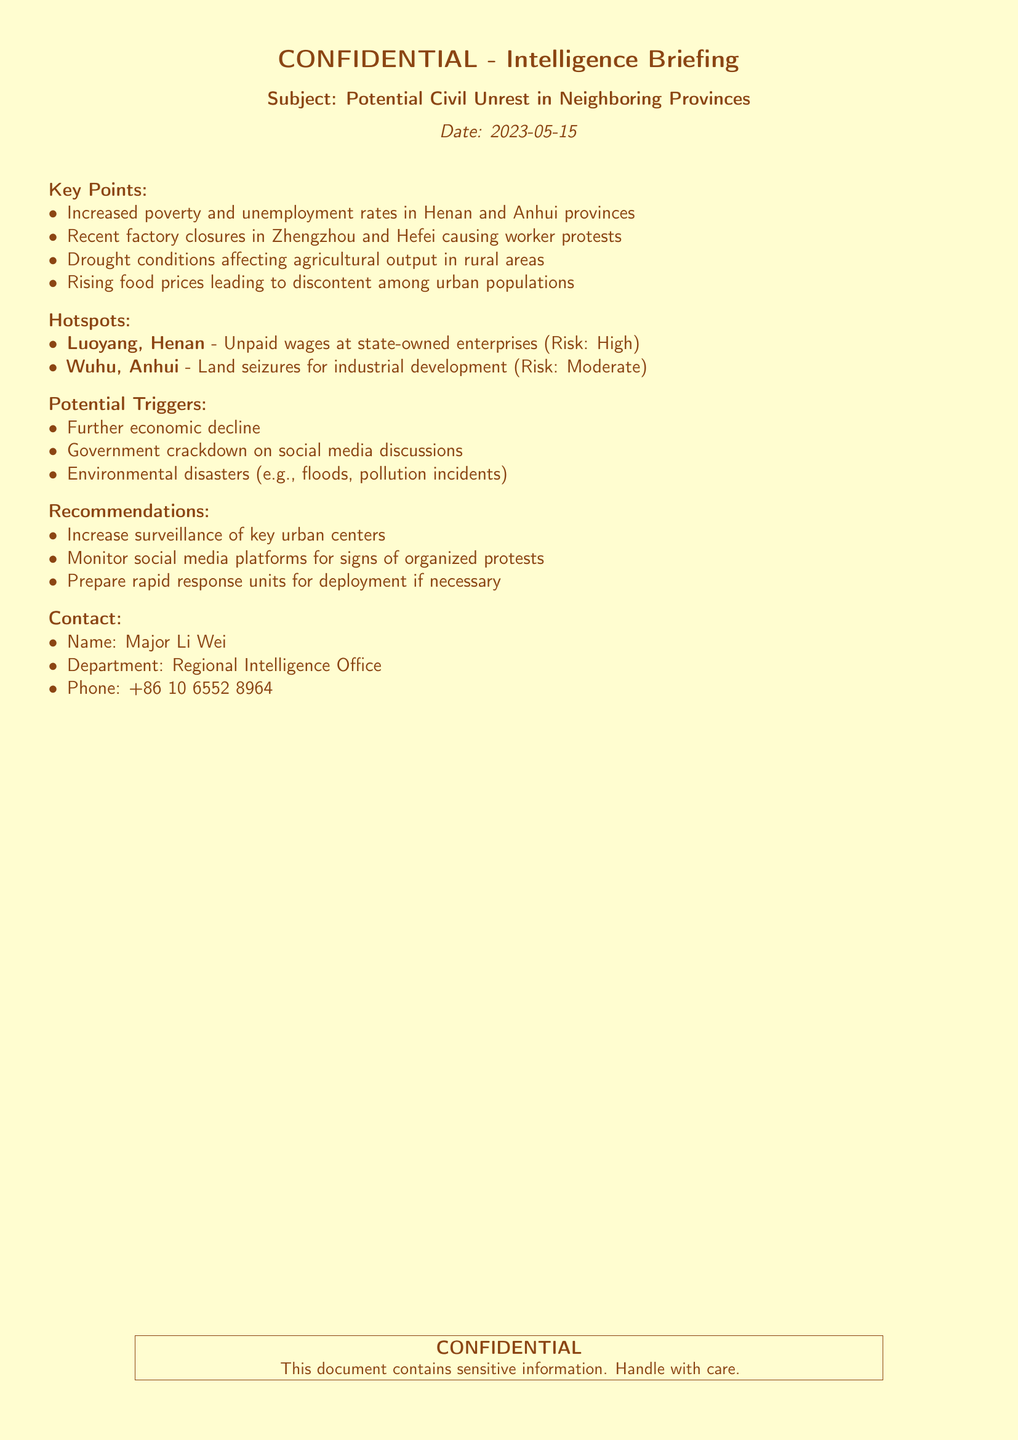what is the date of the intelligence briefing? The date of the briefing is explicitly stated in the document as May 15, 2023.
Answer: May 15, 2023 which provinces are mentioned in the report? The document identifies Henan and Anhui provinces as areas of concern regarding potential civil unrest.
Answer: Henan and Anhui who is the contact person for this briefing? The briefing lists Major Li Wei as the contact for further information regarding the situation.
Answer: Major Li Wei what type of unrest is indicated in Luoyang, Henan? Luoyang is noted for its high-risk situation due to unpaid wages at state-owned enterprises.
Answer: Unpaid wages what are the recommendations provided in the document? The recommendations section of the document advises increasing surveillance, monitoring social media, and preparing rapid response units.
Answer: Increase surveillance, monitor social media, prepare rapid response units what is one potential trigger for unrest mentioned in the document? The document lists further economic decline as one of the potential triggers for civil unrest.
Answer: Further economic decline what is the risk level associated with Wuhu, Anhui? Wuhu is described with a moderate risk level due to land seizures for industrial development.
Answer: Moderate how many key hotspots are identified in the document? The document outlines two key hotspots, indicating areas where unrest is likely to occur.
Answer: Two 